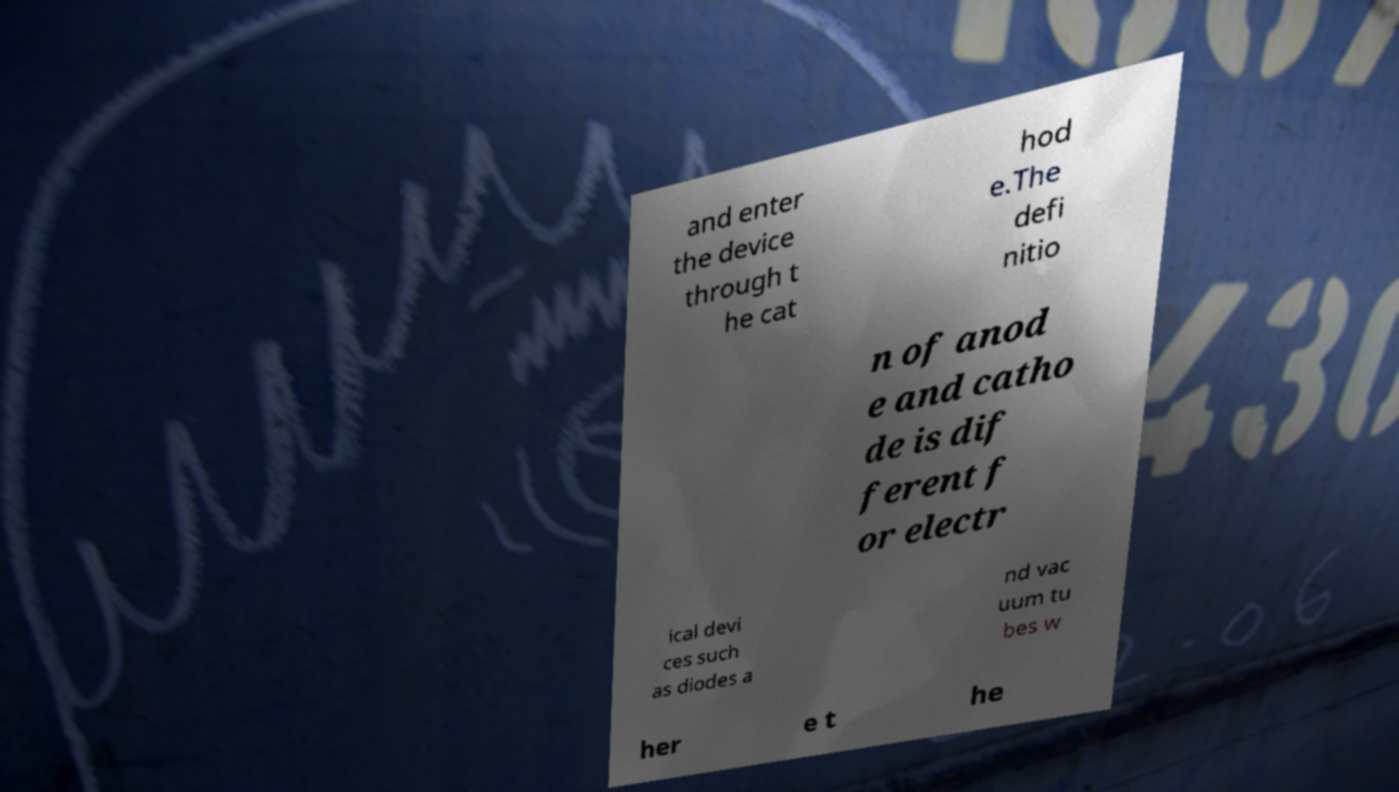There's text embedded in this image that I need extracted. Can you transcribe it verbatim? and enter the device through t he cat hod e.The defi nitio n of anod e and catho de is dif ferent f or electr ical devi ces such as diodes a nd vac uum tu bes w her e t he 